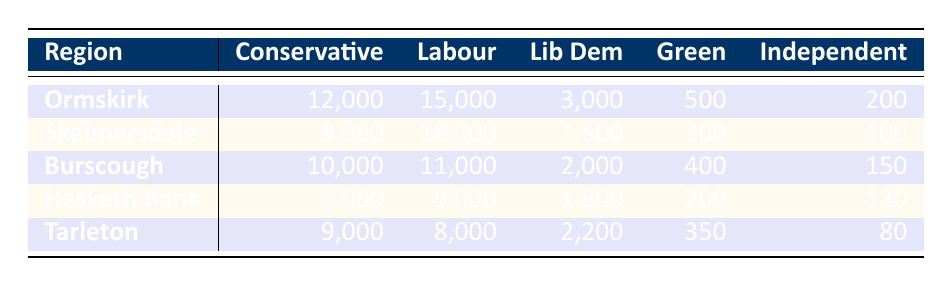What is the total number of Labour voters in Ormskirk? The table shows Labour votes in Ormskirk as 15,000. Since there's only one entry for Ormskirk, the total is simply 15,000.
Answer: 15,000 Which region had the highest number of Conservative voters? In the table, the Conservative votes are 12,000 for Ormskirk, 8,000 for Skelmersdale, 10,000 for Burscough, 7,000 for Hesketh Bank, and 9,000 for Tarleton. The highest is 12,000 in Ormskirk.
Answer: Ormskirk How many Independent votes were cast in Burscough? The table indicates that Burscough had 150 votes for Independent candidates. This is a single data point, and no further calculations are needed.
Answer: 150 What is the average number of votes for Liberal Democrats across all regions? To find the average, sum the Liberal Democrat votes: 3,000 + 1,500 + 2,000 + 1,800 + 2,200 = 10,500. There are 5 regions, so the average is 10,500/5 = 2,100.
Answer: 2,100 Did Hesketh Bank have more Labour voters than Tarleton? Hesketh Bank had 9,000 Labour voters while Tarleton had 8,000. Since 9,000 is greater than 8,000, the statement is true.
Answer: Yes Which region had the lowest number of Green voters? The Green votes listed are 500 in Ormskirk, 300 in Skelmersdale, 400 in Burscough, 200 in Hesketh Bank, and 350 in Tarleton. The lowest is 200, which is from Hesketh Bank.
Answer: Hesketh Bank How many more Labour votes were there in Skelmersdale than in Burscough? Labour votes are 18,000 in Skelmersdale and 11,000 in Burscough. The difference is calculated as 18,000 - 11,000 = 7,000.
Answer: 7,000 What percentage of the total votes in Ormskirk were for the Conservative party? In Ormskirk, the total votes are 12,000 + 15,000 + 3,000 + 500 + 200 = 30,700. The percentage for Conservative is (12,000 / 30,700) * 100, which equals approximately 39.1%.
Answer: 39.1% Was the number of Liberal Democrats voters higher in Tarleton or Skelmersdale? Tarleton had 2,200 Liberal Democrat votes and Skelmersdale had 1,500. Since 2,200 is greater than 1,500, Tarleton had more.
Answer: Yes 